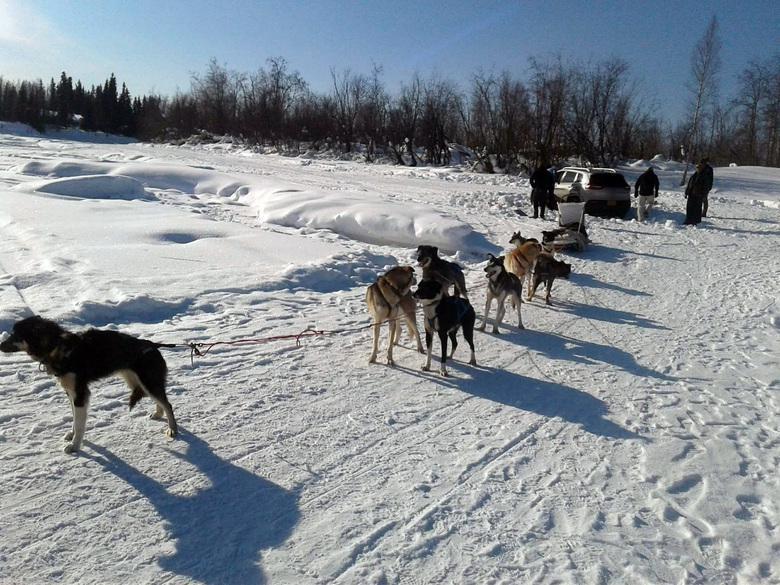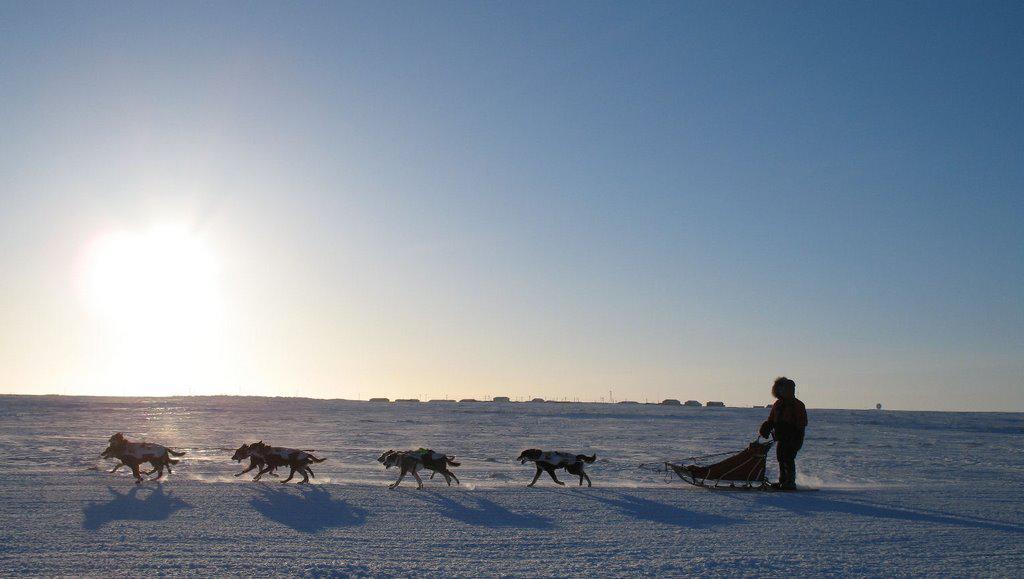The first image is the image on the left, the second image is the image on the right. For the images displayed, is the sentence "A dogsled is traveling slightly to the right in at least one of the images." factually correct? Answer yes or no. No. The first image is the image on the left, the second image is the image on the right. Analyze the images presented: Is the assertion "A building with a snow-covered peaked roof is in the background of an image with at least one sled dog team racing across the snow." valid? Answer yes or no. No. 